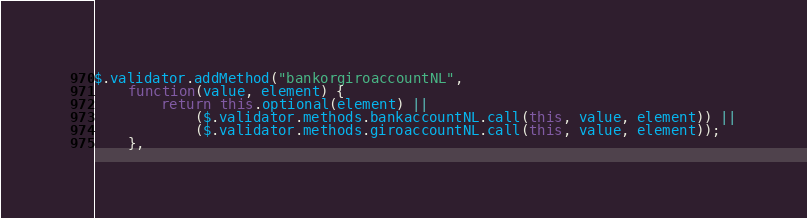Convert code to text. <code><loc_0><loc_0><loc_500><loc_500><_JavaScript_>$.validator.addMethod("bankorgiroaccountNL",
    function(value, element) {
        return this.optional(element) ||
            ($.validator.methods.bankaccountNL.call(this, value, element)) ||
            ($.validator.methods.giroaccountNL.call(this, value, element));
    },</code> 